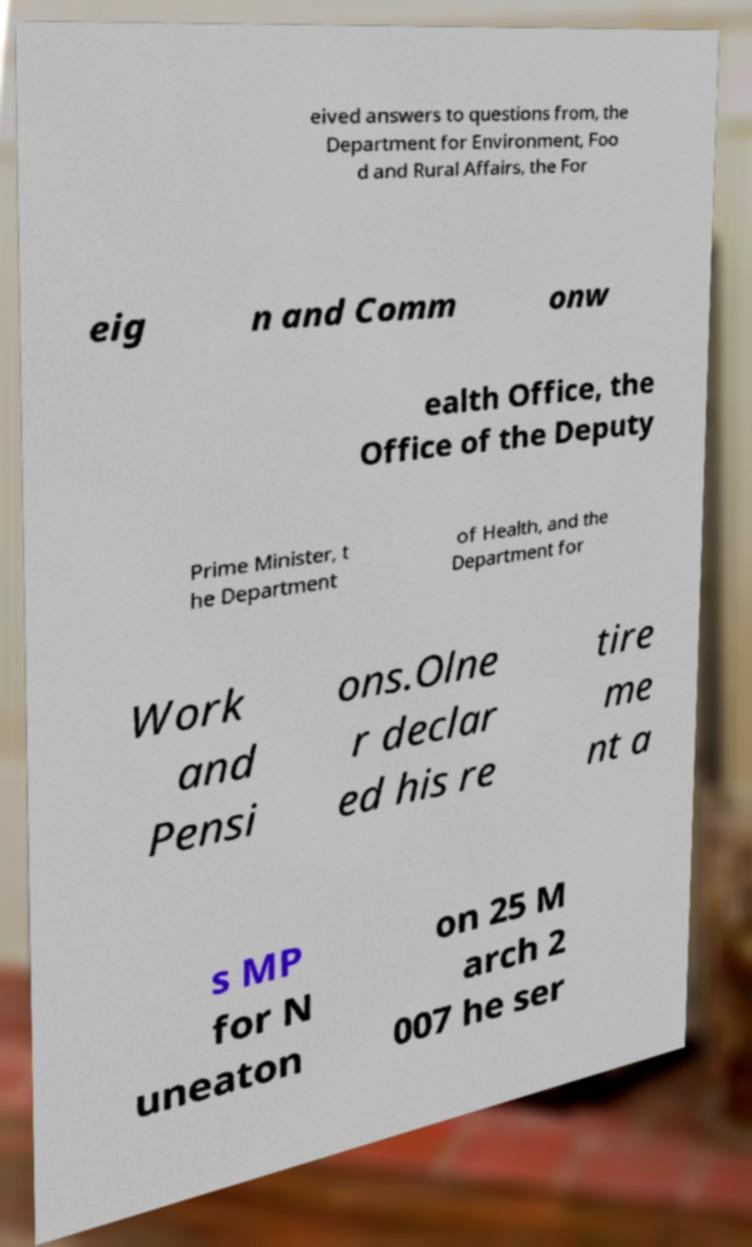What messages or text are displayed in this image? I need them in a readable, typed format. eived answers to questions from, the Department for Environment, Foo d and Rural Affairs, the For eig n and Comm onw ealth Office, the Office of the Deputy Prime Minister, t he Department of Health, and the Department for Work and Pensi ons.Olne r declar ed his re tire me nt a s MP for N uneaton on 25 M arch 2 007 he ser 